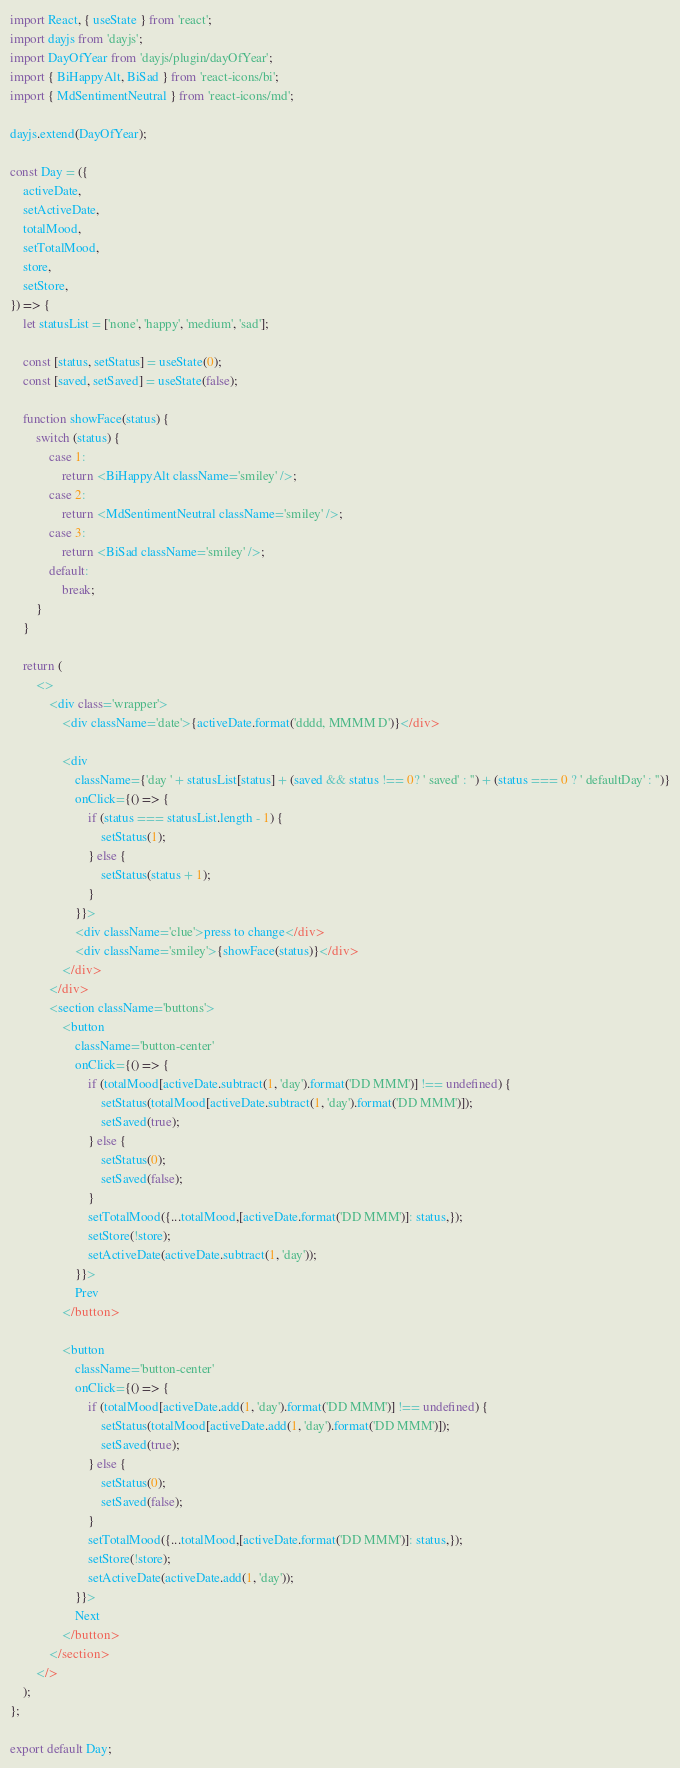<code> <loc_0><loc_0><loc_500><loc_500><_JavaScript_>import React, { useState } from 'react';
import dayjs from 'dayjs';
import DayOfYear from 'dayjs/plugin/dayOfYear';
import { BiHappyAlt, BiSad } from 'react-icons/bi';
import { MdSentimentNeutral } from 'react-icons/md';

dayjs.extend(DayOfYear);

const Day = ({
    activeDate,
    setActiveDate,
    totalMood,
    setTotalMood,
    store,
    setStore,
}) => {
    let statusList = ['none', 'happy', 'medium', 'sad'];
    
    const [status, setStatus] = useState(0);
    const [saved, setSaved] = useState(false);

    function showFace(status) {
        switch (status) {
            case 1:
                return <BiHappyAlt className='smiley' />;
            case 2:
                return <MdSentimentNeutral className='smiley' />;
            case 3:
                return <BiSad className='smiley' />;
            default:
                break;
        }
    }

    return (
        <>
            <div class='wrapper'>
                <div className='date'>{activeDate.format('dddd, MMMM D')}</div>

                <div
                    className={'day ' + statusList[status] + (saved && status !== 0? ' saved' : '') + (status === 0 ? ' defaultDay' : '')}
                    onClick={() => {
                        if (status === statusList.length - 1) {
                            setStatus(1);
                        } else {
                            setStatus(status + 1);
                        }
                    }}>
                    <div className='clue'>press to change</div>
                    <div className='smiley'>{showFace(status)}</div>
                </div>
            </div>
            <section className='buttons'>
                <button
                    className='button-center'
                    onClick={() => {
                        if (totalMood[activeDate.subtract(1, 'day').format('DD MMM')] !== undefined) {
                            setStatus(totalMood[activeDate.subtract(1, 'day').format('DD MMM')]);
                            setSaved(true);
                        } else {
                            setStatus(0);
                            setSaved(false);
                        }
                        setTotalMood({...totalMood,[activeDate.format('DD MMM')]: status,});
                        setStore(!store);
                        setActiveDate(activeDate.subtract(1, 'day'));
                    }}>
                    Prev
                </button>

                <button
                    className='button-center'
                    onClick={() => {
                        if (totalMood[activeDate.add(1, 'day').format('DD MMM')] !== undefined) {
                            setStatus(totalMood[activeDate.add(1, 'day').format('DD MMM')]);
                            setSaved(true);
                        } else {
                            setStatus(0);
                            setSaved(false);
                        }
                        setTotalMood({...totalMood,[activeDate.format('DD MMM')]: status,});
                        setStore(!store);
                        setActiveDate(activeDate.add(1, 'day'));
                    }}>
                    Next
                </button>
            </section>
        </>
    );
};

export default Day;
</code> 